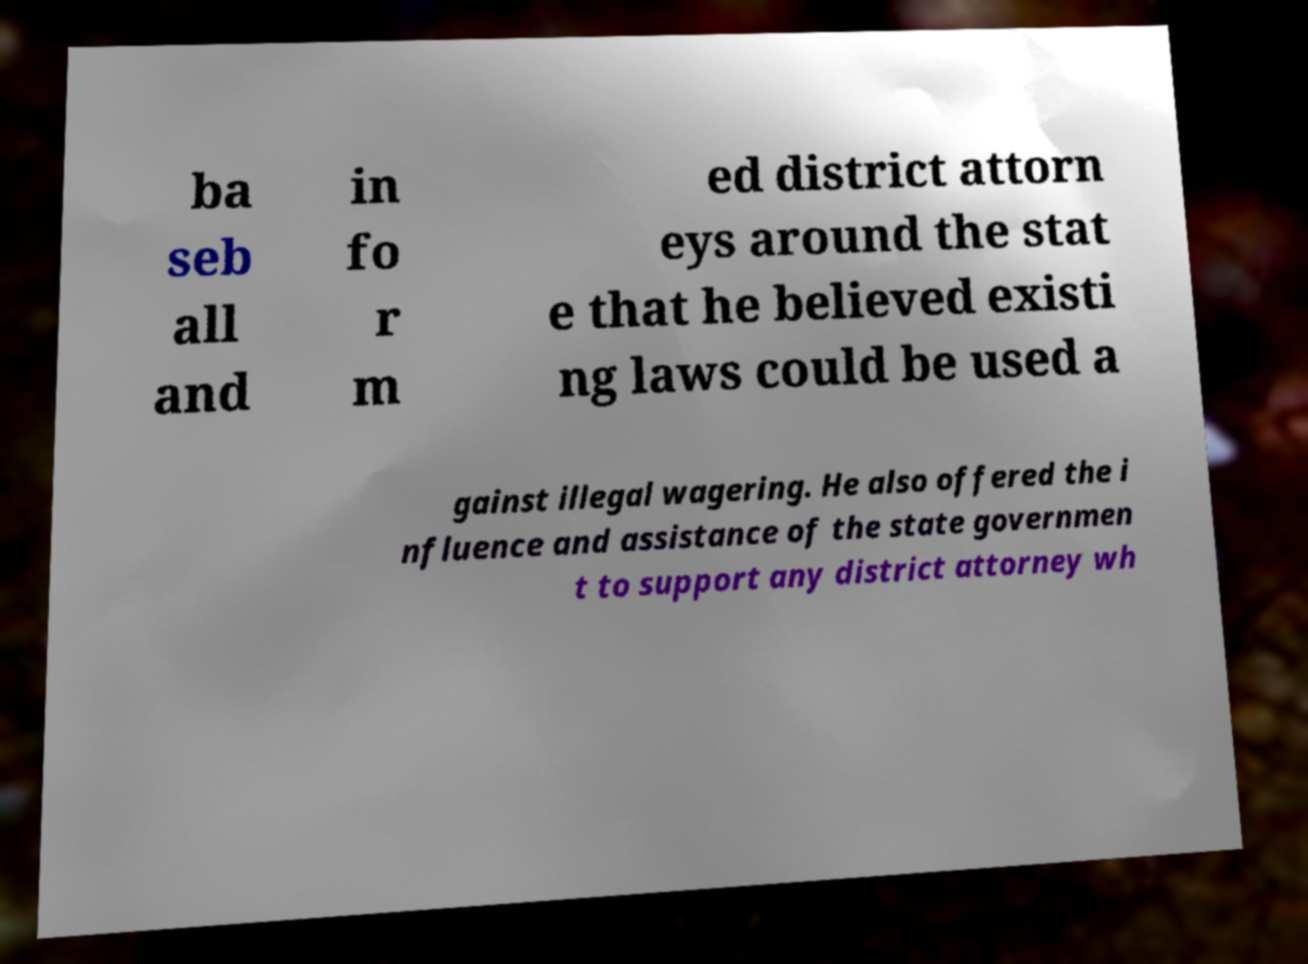Please identify and transcribe the text found in this image. ba seb all and in fo r m ed district attorn eys around the stat e that he believed existi ng laws could be used a gainst illegal wagering. He also offered the i nfluence and assistance of the state governmen t to support any district attorney wh 